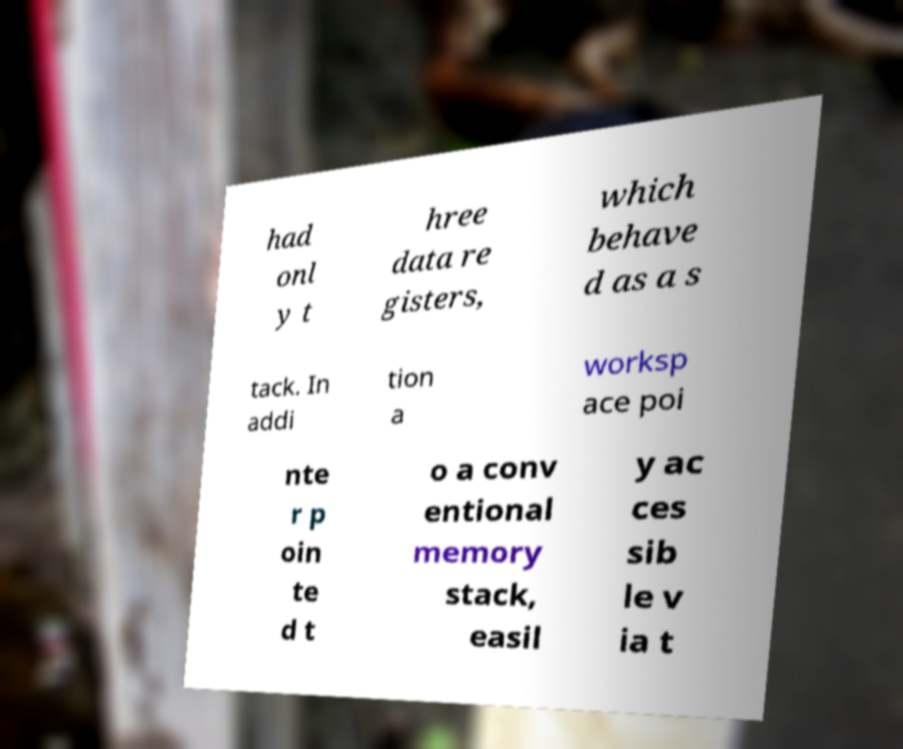Can you read and provide the text displayed in the image?This photo seems to have some interesting text. Can you extract and type it out for me? had onl y t hree data re gisters, which behave d as a s tack. In addi tion a worksp ace poi nte r p oin te d t o a conv entional memory stack, easil y ac ces sib le v ia t 